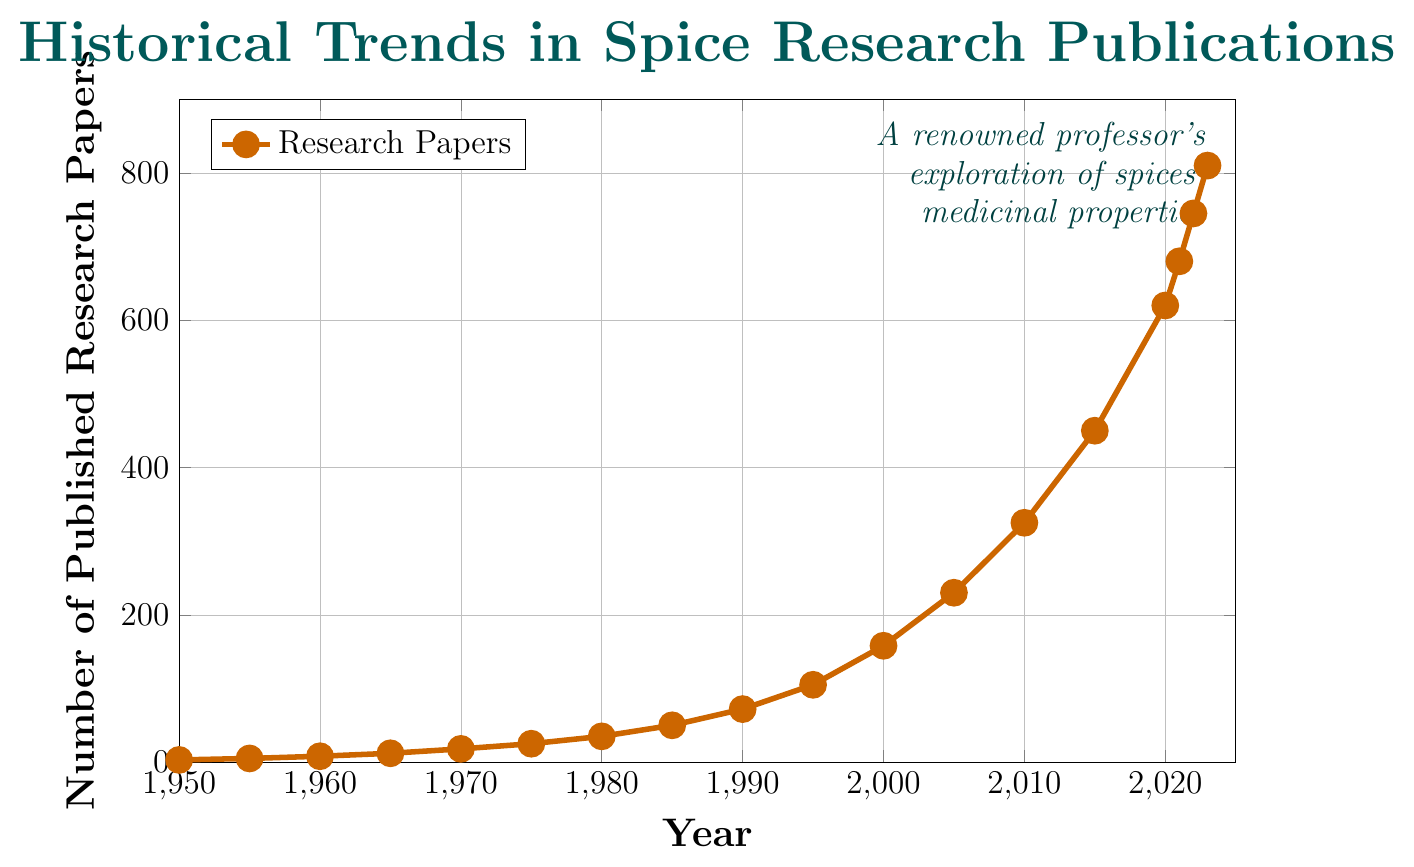What is the earliest year in the dataset? Look at the x-axis of the plot, and the first point starts at the year 1950.
Answer: 1950 How many research papers were published in the year 1980? Find the point corresponding to 1980 on the x-axis and see where it aligns with the y-axis. The number is 35.
Answer: 35 Between which years did the number of research papers published increase the most? Compare the intervals between each pair of consecutive points on the plot. The steepest increase is from 2015 (450) to 2020 (620), an increase of 170 papers.
Answer: 2015 and 2020 What is the average number of research papers published per decade from 1950 to 1990? Compute the average for each decade: 
    - 1950-1959: (3 + 5) / 2 = 4
    - 1960-1969: (8 + 12) / 2 = 10
    - 1970-1979: (18 + 25) / 2 = 21.5
    - 1980-1989: (35 + 50) / 2 = 42.5
Then average those four results: (4 + 10 + 21.5 + 42.5) / 4 = 19.5
Answer: 19.5 By how much did the number of research papers increase from 2000 to 2023? Subtract the number of papers in 2000 from the number of papers in 2023: 810 - 158 = 652
Answer: 652 What color is used to plot the data points and lines in the graph? Observe the color of the points and lines in the plot. They are orange.
Answer: Orange Which year had the very first noticeable rapid increase in the number of published research papers? The plot shows a noticeable increase between every two sets of years, but the first substantial increase happens from 1970 (18) to 1980 (35).
Answer: Between 1970 and 1980 How steep was the increase between 1995 and 2000, and how does it compare to the increase between 2020 and 2023? - For 1995-2000: 158 - 105 = 53
    - For 2020-2023: 810 - 620 = 190
To compare, the increase between 2020 and 2023 is larger (190 vs. 53).
Answer: 2020 to 2023 is larger What is the total number of research papers published from 1950 to 1970? Add the numbers from 1950, 1955, 1960, 1965, and 1970: 3 + 5 + 8 + 12 + 18 = 46
Answer: 46 How many more research papers were published in 2023 compared to 2021? Subtract the number of papers in 2021 from the number in 2023: 810 - 680 = 130
Answer: 130 